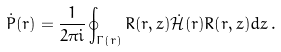<formula> <loc_0><loc_0><loc_500><loc_500>\dot { P } ( r ) = \frac { 1 } { 2 \pi i } \oint _ { \Gamma ( r ) } R ( r , z ) \dot { \mathcal { H } } ( r ) R ( r , z ) d z \, .</formula> 